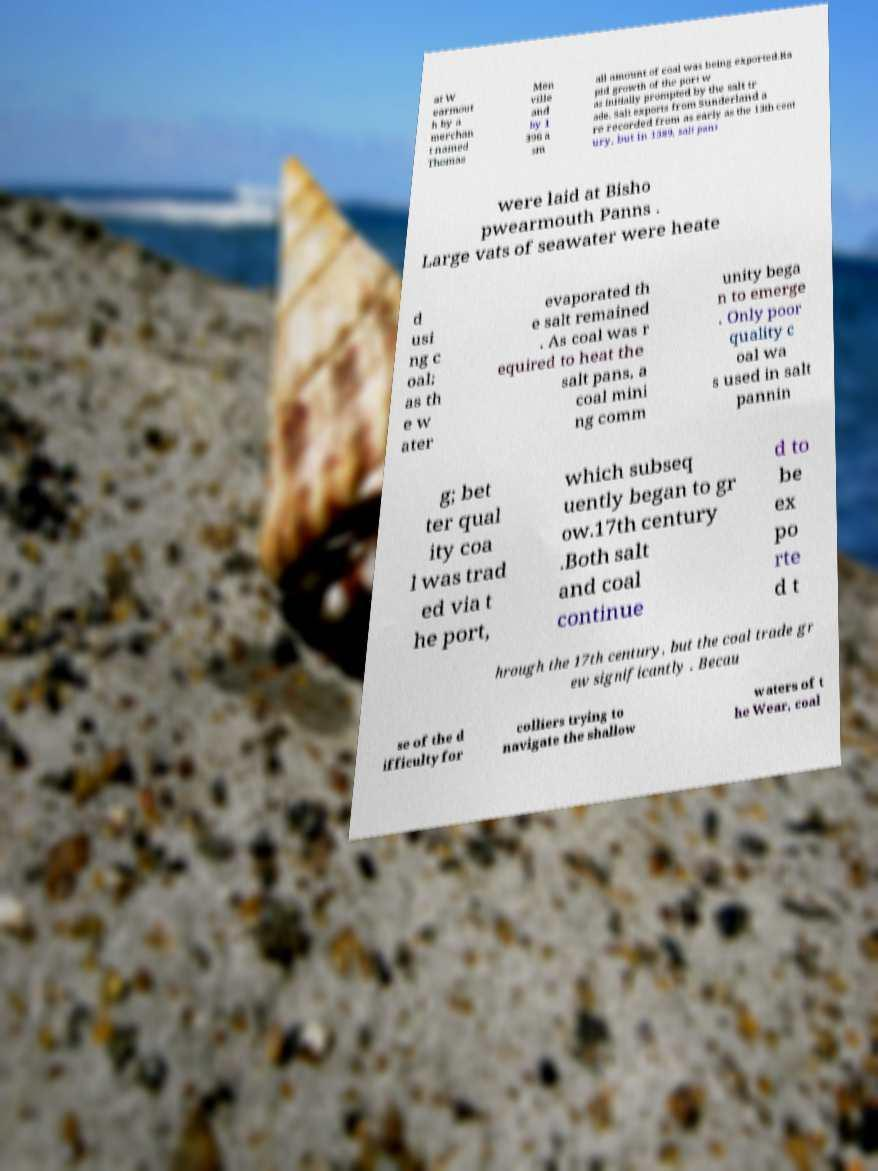Can you accurately transcribe the text from the provided image for me? at W earmout h by a merchan t named Thomas Men ville and by 1 396 a sm all amount of coal was being exported.Ra pid growth of the port w as initially prompted by the salt tr ade. Salt exports from Sunderland a re recorded from as early as the 13th cent ury, but In 1589, salt pans were laid at Bisho pwearmouth Panns . Large vats of seawater were heate d usi ng c oal; as th e w ater evaporated th e salt remained . As coal was r equired to heat the salt pans, a coal mini ng comm unity bega n to emerge . Only poor quality c oal wa s used in salt pannin g; bet ter qual ity coa l was trad ed via t he port, which subseq uently began to gr ow.17th century .Both salt and coal continue d to be ex po rte d t hrough the 17th century, but the coal trade gr ew significantly . Becau se of the d ifficulty for colliers trying to navigate the shallow waters of t he Wear, coal 